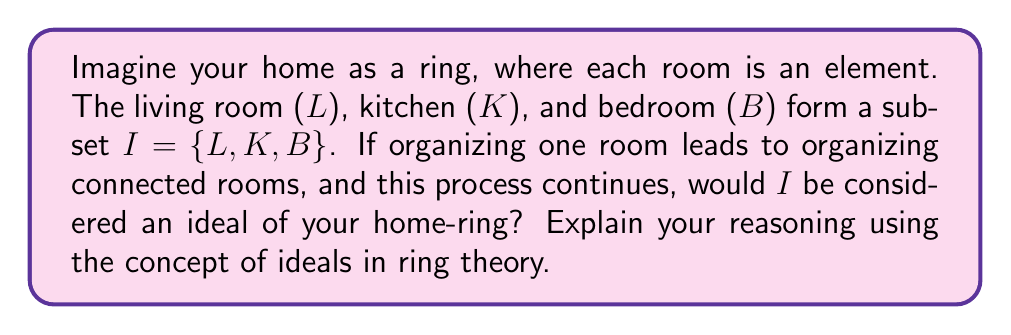Can you answer this question? Let's break this down step-by-step using concepts from ring theory, but relating them to home organization:

1. Ring definition: In this scenario, your home is the ring. Each room is an element of this ring.

2. Subset I: The subset I = {L, K, B} represents the living room, kitchen, and bedroom.

3. Ideal properties: For I to be an ideal, it must satisfy two conditions:
   a. Closure under subtraction: For any two elements a, b in I, their difference (a - b) must also be in I.
   b. Absorption property: For any element r in the ring and any element a in I, both ra and ar must be in I.

4. Interpreting these properties in our home scenario:
   a. Closure under subtraction: If you organize one room and then another, the result should still be within the subset I.
   b. Absorption property: If you organize a room in I and this affects any other room in the house (ring), the result should still be within I.

5. Analyzing the given information:
   - "Organizing one room leads to organizing connected rooms" suggests that the absorption property might hold.
   - However, we don't have information about all rooms in the house or how they're connected.

6. Potential issues:
   - If there are rooms outside of I that get organized as a result of organizing rooms in I, then I would not be an ideal.
   - We don't have information about how "subtraction" would work in this context, making it difficult to verify the closure under subtraction property.

Given the limited information and the abstract nature of applying ring theory to home organization, we cannot conclusively determine if I is an ideal. More specific rules about how organization spreads and affects other rooms would be needed to make a definitive statement.
Answer: Based on the given information, it cannot be conclusively determined whether I = {L, K, B} is an ideal of the home-ring. More specific details about the relationships between all rooms and how organization affects them would be needed to verify the properties of an ideal. 